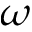Convert formula to latex. <formula><loc_0><loc_0><loc_500><loc_500>\omega</formula> 